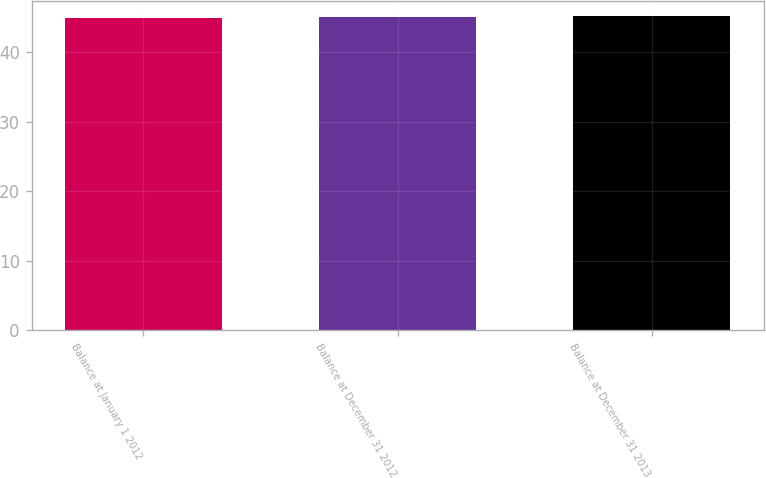Convert chart to OTSL. <chart><loc_0><loc_0><loc_500><loc_500><bar_chart><fcel>Balance at January 1 2012<fcel>Balance at December 31 2012<fcel>Balance at December 31 2013<nl><fcel>45<fcel>45.1<fcel>45.2<nl></chart> 